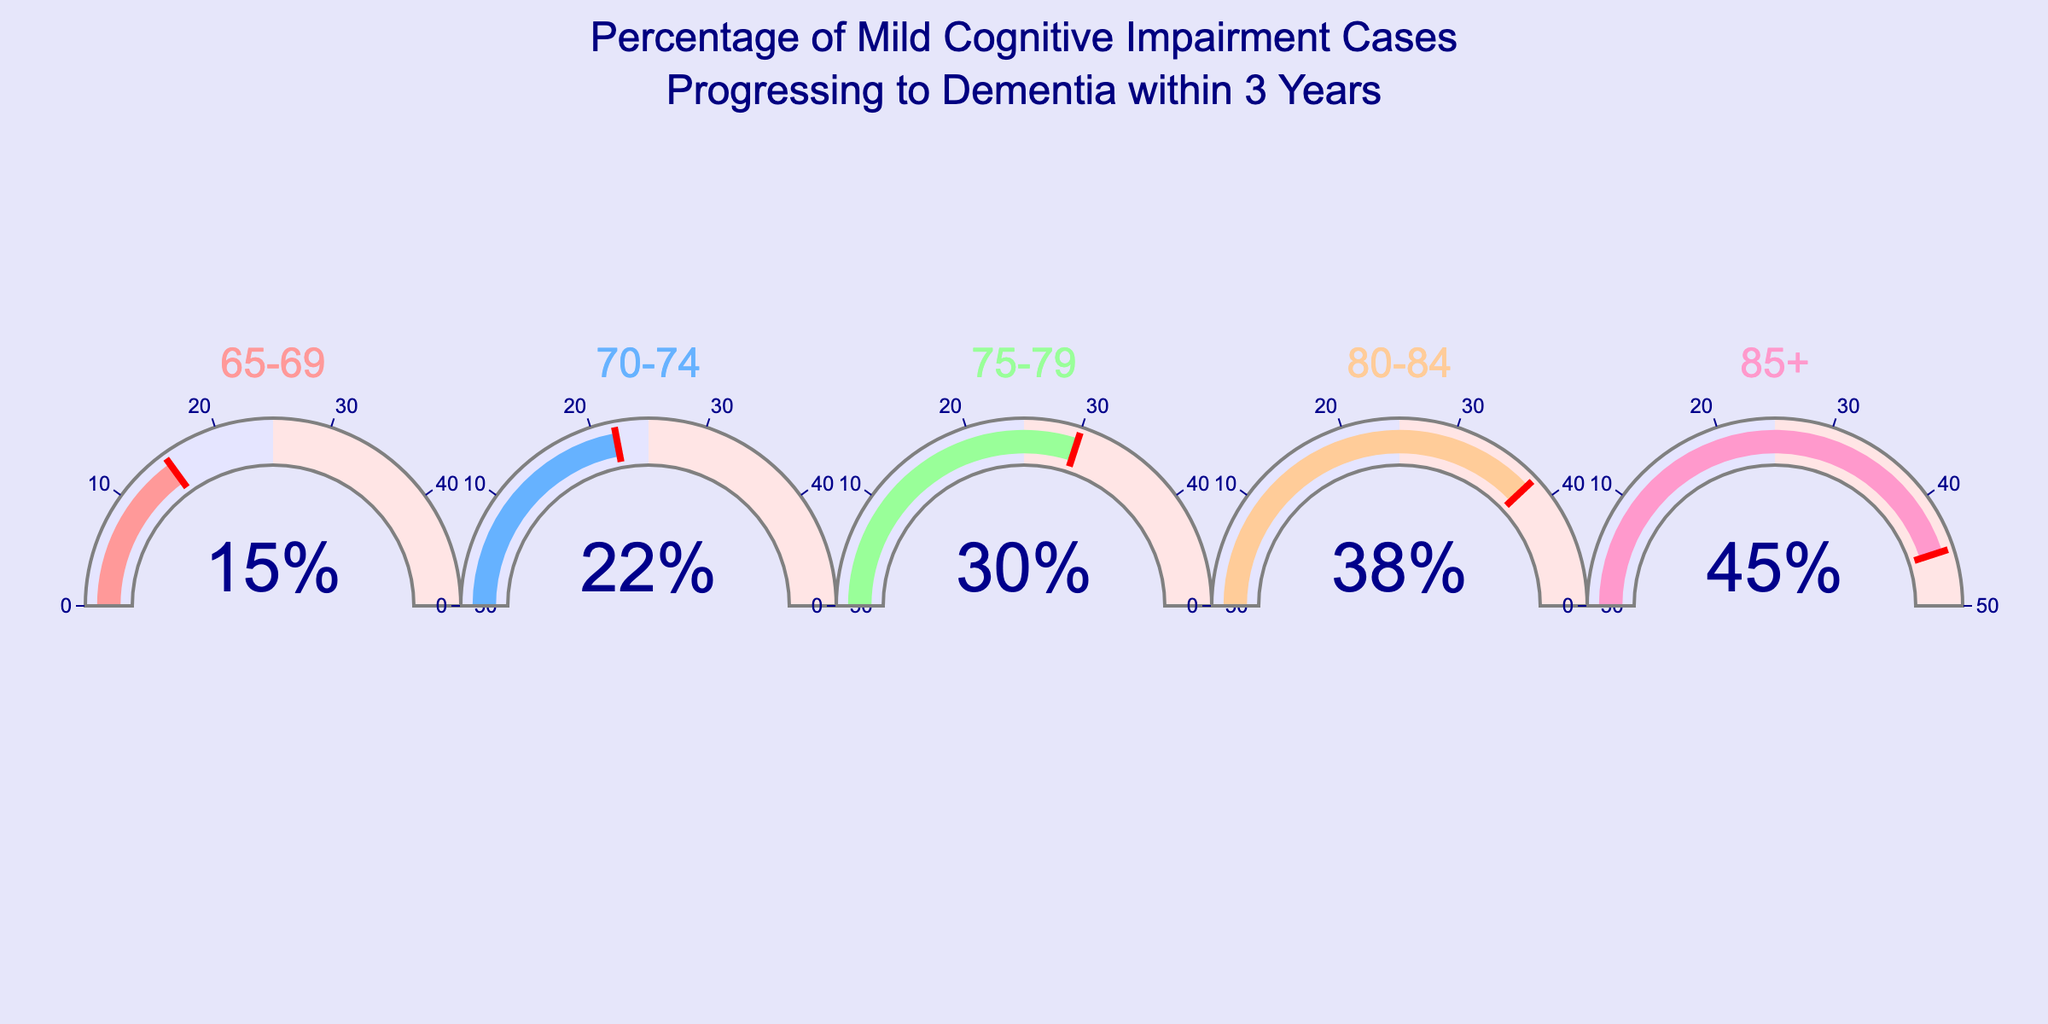What's the title of the figure? The title of a figure is usually displayed at the top, and in this plot, it reads "Percentage of Mild Cognitive Impairment Cases Progressing to Dementia within 3 Years"
Answer: Percentage of Mild Cognitive Impairment Cases Progressing to Dementia within 3 Years How many age groups are represented in the figure? By counting the individual gauges, we can see that there are five age groups represented.
Answer: 5 Which age group has the highest progression rate to dementia? By observing the gauge with the highest value, we find that the "85+" age group has the highest progression rate at 45%.
Answer: 85+ What is the progression rate for the 70-74 age group? Locate the gauge corresponding to the "70-74" age group and read the number displayed on it, which is 22%.
Answer: 22% Compare the progression rates of the 65-69 and 75-79 age groups. Which one is higher? The progression rate for the 65-69 age group is 15%, while for the 75-79 age group, it's 30%. Therefore, the rate for the 75-79 age group is higher.
Answer: 75-79 What is the average progression rate across all age groups? Add the progression rates for all age groups (15, 22, 30, 38, 45) and divide by the number of age groups (5). Calculation: (15 + 22 + 30 + 38 + 45) / 5 = 30%
Answer: 30% How does the progression rate of the 80-84 age group compare to the overall average rate? The progression rate for the 80-84 age group is 38%. The overall average progression rate is 30%. Comparing these values, the rate for the 80-84 age group is higher than the overall average.
Answer: Higher What's the difference in progression rates between the youngest and oldest age groups? Subtract the progression rate of the 65-69 age group (15%) from that of the 85+ age group (45%). Calculation: 45% - 15% = 30%
Answer: 30% Are there any age groups with a progression rate below 20%? Examine each gauge and identify any age group with a value less than 20%. The 65-69 age group has a rate of 15%, which is below 20%.
Answer: Yes What color is used for the gauge of the 75-79 age group? Identify the color of the gauge corresponding to the 75-79 age group, which is green.
Answer: Green 